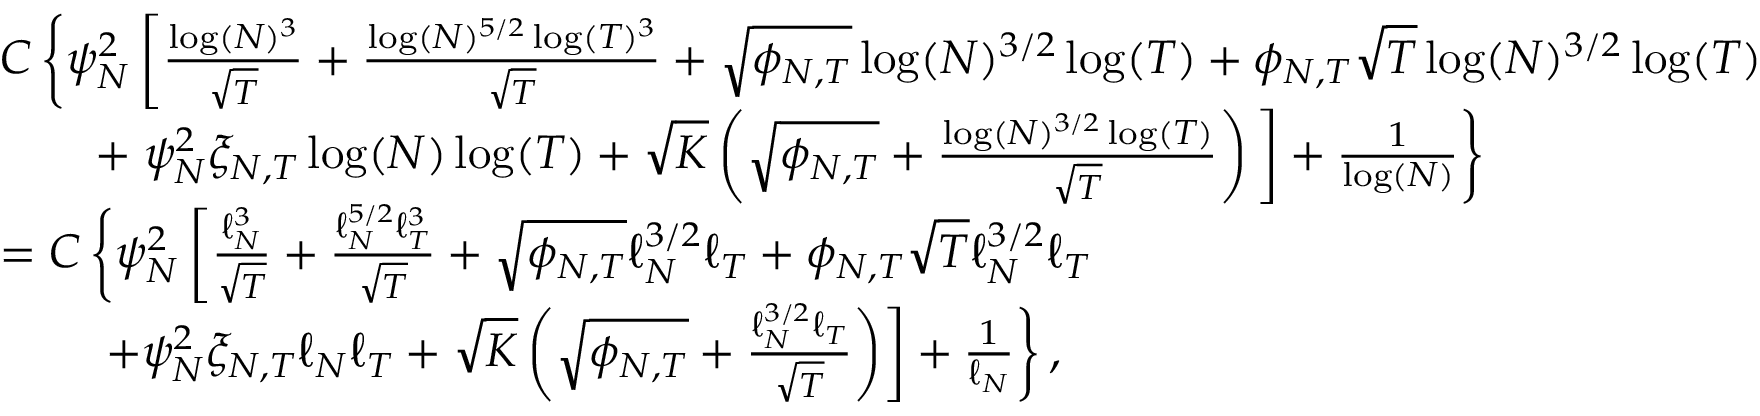<formula> <loc_0><loc_0><loc_500><loc_500>\begin{array} { r l } & { C \left \{ \psi _ { N } ^ { 2 } \left [ \frac { \log ( N ) ^ { 3 } } { \sqrt { T } } + \frac { \log ( N ) ^ { 5 / 2 } \log ( T ) ^ { 3 } } { \sqrt { T } } + \sqrt { \phi _ { N , T } } \log ( N ) ^ { 3 / 2 } \log ( T ) + \phi _ { N , T } \sqrt { T } \log ( N ) ^ { 3 / 2 } \log ( T ) } \\ & { \quad + \psi _ { N } ^ { 2 } \xi _ { N , T } \log ( N ) \log ( T ) + \sqrt { K } \left ( \sqrt { \phi _ { N , T } } + \frac { \log ( N ) ^ { 3 / 2 } \log ( T ) } { \sqrt { T } } \right ) \Big ] + \frac { 1 } { \log ( N ) } \right \} } \\ & { = C \left \{ \psi _ { N } ^ { 2 } \left [ \frac { \ell _ { N } ^ { 3 } } { \sqrt { T } } + \frac { \ell _ { N } ^ { 5 / 2 } \ell _ { T } ^ { 3 } } { \sqrt { T } } + \sqrt { \phi _ { N , T } } \ell _ { N } ^ { 3 / 2 } \ell _ { T } + \phi _ { N , T } \sqrt { T } \ell _ { N } ^ { 3 / 2 } \ell _ { T } } \\ & { \quad + \psi _ { N } ^ { 2 } \xi _ { N , T } \ell _ { N } \ell _ { T } + \sqrt { K } \left ( \sqrt { \phi _ { N , T } } + \frac { \ell _ { N } ^ { 3 / 2 } \ell _ { T } } { \sqrt { T } } \right ) \right ] + \frac { 1 } { \ell _ { N } } \right \} , } \end{array}</formula> 